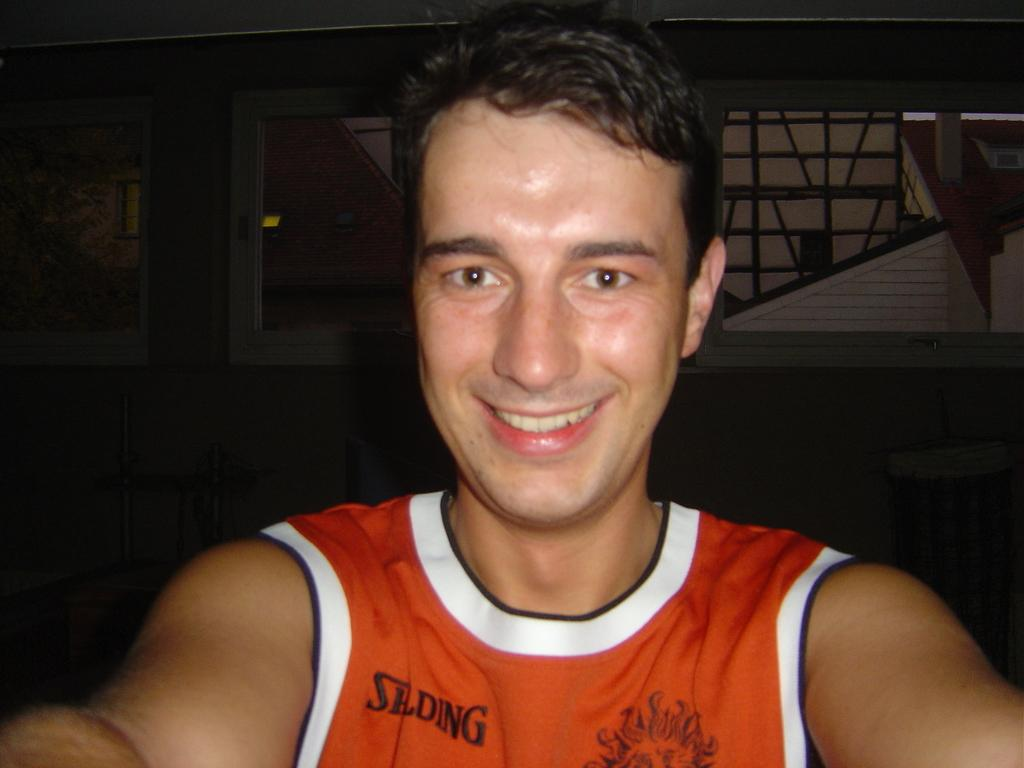<image>
Offer a succinct explanation of the picture presented. a man wearing an orange shirt that says 'spalding' on it 